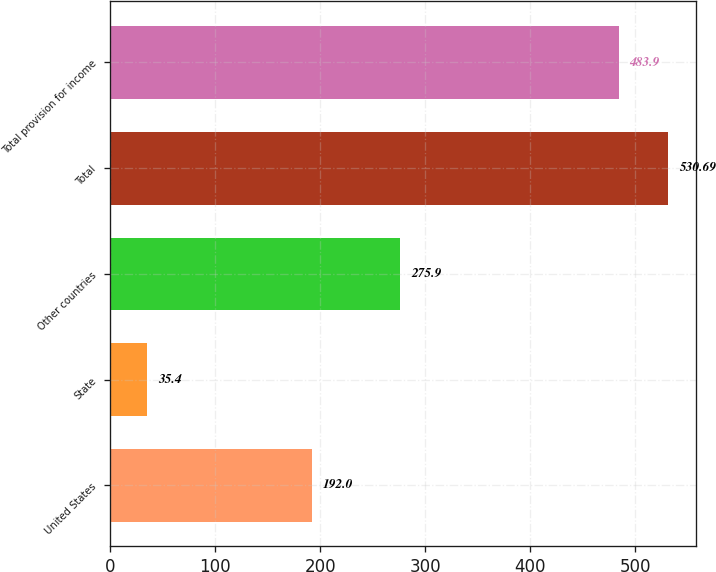<chart> <loc_0><loc_0><loc_500><loc_500><bar_chart><fcel>United States<fcel>State<fcel>Other countries<fcel>Total<fcel>Total provision for income<nl><fcel>192<fcel>35.4<fcel>275.9<fcel>530.69<fcel>483.9<nl></chart> 